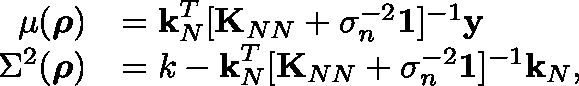<formula> <loc_0><loc_0><loc_500><loc_500>\begin{array} { r l } { \mu ( \rho ) } & { = k _ { N } ^ { T } [ K _ { N N } + \sigma _ { n } ^ { - 2 } \mathbb { 1 } ] ^ { - 1 } y } \\ { \Sigma ^ { 2 } ( \rho ) } & { = k - k _ { N } ^ { T } [ K _ { N N } + \sigma _ { n } ^ { - 2 } \mathbb { 1 } ] ^ { - 1 } k _ { N } , } \end{array}</formula> 